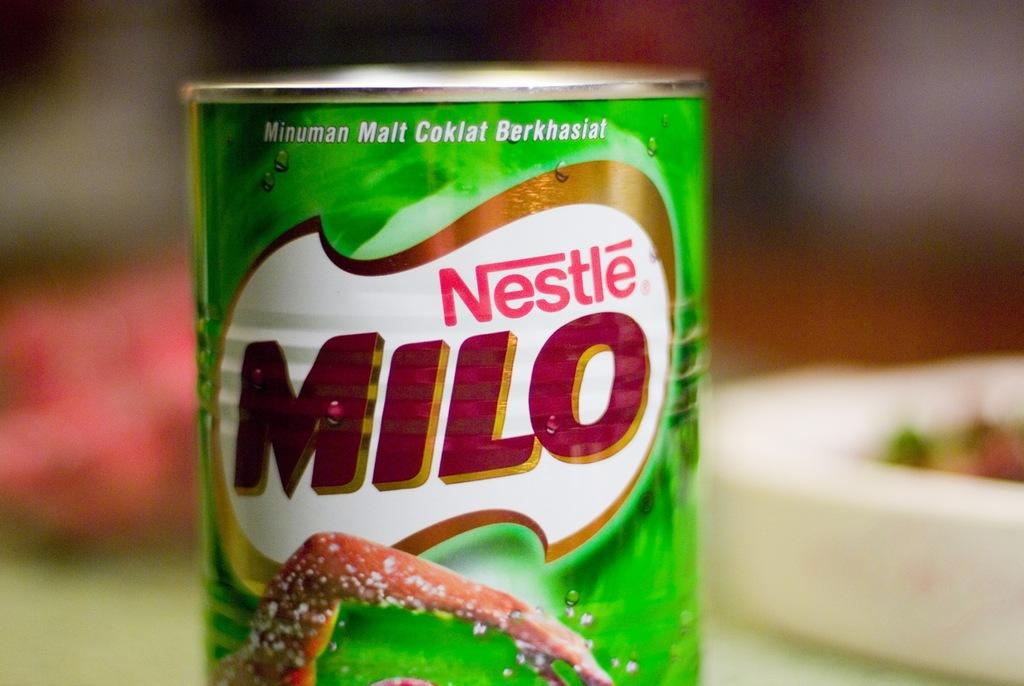What is the main subject of the image? The main subject of the image is a milo drink jar. Where is the milo drink jar located in the image? The milo drink jar is in the center of the image. What type of birds can be seen flying around the milo drink jar in the image? There are no birds present in the image; it only features a milo drink jar in the center. 